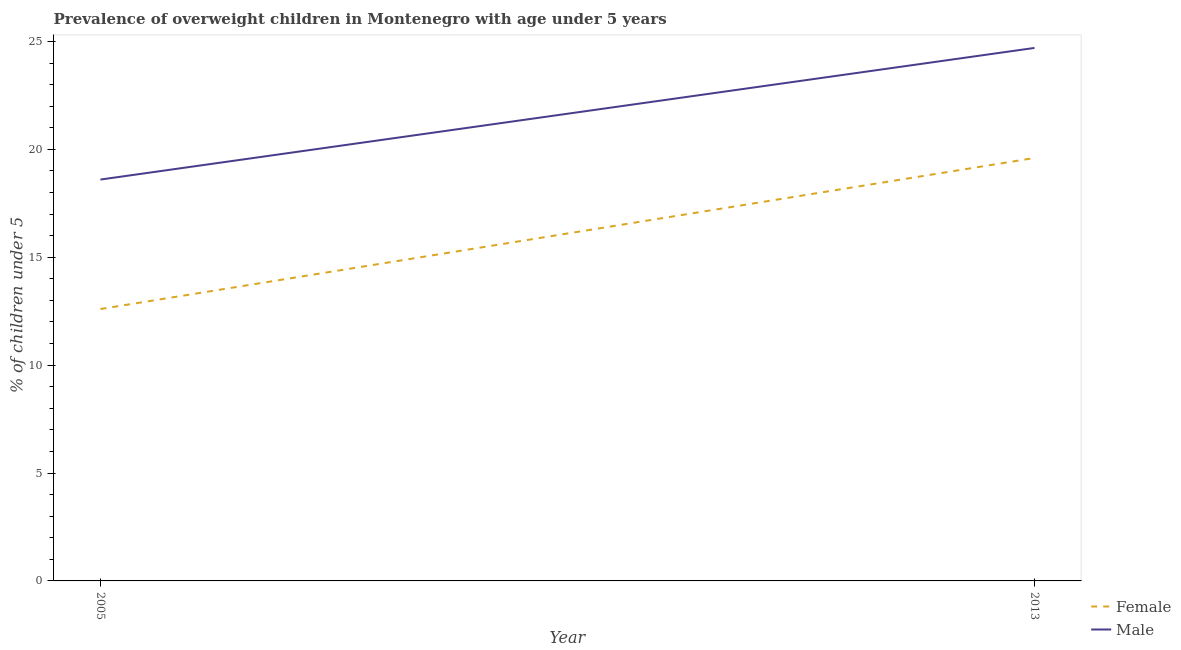Is the number of lines equal to the number of legend labels?
Offer a terse response. Yes. What is the percentage of obese female children in 2013?
Your answer should be compact. 19.6. Across all years, what is the maximum percentage of obese male children?
Your response must be concise. 24.7. Across all years, what is the minimum percentage of obese male children?
Keep it short and to the point. 18.6. In which year was the percentage of obese female children minimum?
Provide a short and direct response. 2005. What is the total percentage of obese female children in the graph?
Offer a very short reply. 32.2. What is the difference between the percentage of obese female children in 2005 and that in 2013?
Offer a very short reply. -7. What is the average percentage of obese male children per year?
Your answer should be compact. 21.65. In the year 2005, what is the difference between the percentage of obese male children and percentage of obese female children?
Give a very brief answer. 6. What is the ratio of the percentage of obese female children in 2005 to that in 2013?
Provide a succinct answer. 0.64. Is the percentage of obese male children in 2005 less than that in 2013?
Your answer should be very brief. Yes. Does the percentage of obese male children monotonically increase over the years?
Your response must be concise. Yes. Is the percentage of obese female children strictly greater than the percentage of obese male children over the years?
Keep it short and to the point. No. Is the percentage of obese female children strictly less than the percentage of obese male children over the years?
Provide a succinct answer. Yes. How many lines are there?
Give a very brief answer. 2. How many years are there in the graph?
Make the answer very short. 2. Does the graph contain any zero values?
Make the answer very short. No. How are the legend labels stacked?
Provide a succinct answer. Vertical. What is the title of the graph?
Ensure brevity in your answer.  Prevalence of overweight children in Montenegro with age under 5 years. Does "Age 65(male)" appear as one of the legend labels in the graph?
Give a very brief answer. No. What is the label or title of the Y-axis?
Give a very brief answer.  % of children under 5. What is the  % of children under 5 in Female in 2005?
Ensure brevity in your answer.  12.6. What is the  % of children under 5 in Male in 2005?
Make the answer very short. 18.6. What is the  % of children under 5 of Female in 2013?
Your response must be concise. 19.6. What is the  % of children under 5 in Male in 2013?
Provide a short and direct response. 24.7. Across all years, what is the maximum  % of children under 5 in Female?
Offer a terse response. 19.6. Across all years, what is the maximum  % of children under 5 in Male?
Give a very brief answer. 24.7. Across all years, what is the minimum  % of children under 5 of Female?
Provide a succinct answer. 12.6. Across all years, what is the minimum  % of children under 5 of Male?
Provide a succinct answer. 18.6. What is the total  % of children under 5 in Female in the graph?
Your response must be concise. 32.2. What is the total  % of children under 5 of Male in the graph?
Provide a short and direct response. 43.3. What is the difference between the  % of children under 5 in Male in 2005 and that in 2013?
Your answer should be compact. -6.1. What is the average  % of children under 5 in Female per year?
Offer a terse response. 16.1. What is the average  % of children under 5 in Male per year?
Provide a succinct answer. 21.65. What is the ratio of the  % of children under 5 in Female in 2005 to that in 2013?
Keep it short and to the point. 0.64. What is the ratio of the  % of children under 5 of Male in 2005 to that in 2013?
Provide a short and direct response. 0.75. What is the difference between the highest and the second highest  % of children under 5 in Female?
Your answer should be compact. 7. What is the difference between the highest and the second highest  % of children under 5 of Male?
Provide a short and direct response. 6.1. 